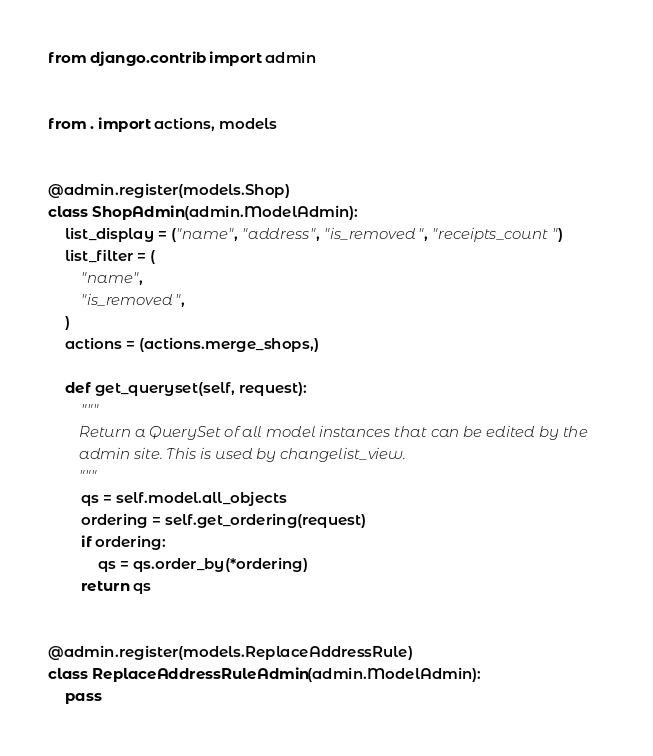<code> <loc_0><loc_0><loc_500><loc_500><_Python_>from django.contrib import admin


from . import actions, models


@admin.register(models.Shop)
class ShopAdmin(admin.ModelAdmin):
    list_display = ("name", "address", "is_removed", "receipts_count")
    list_filter = (
        "name",
        "is_removed",
    )
    actions = (actions.merge_shops,)

    def get_queryset(self, request):
        """
        Return a QuerySet of all model instances that can be edited by the
        admin site. This is used by changelist_view.
        """
        qs = self.model.all_objects
        ordering = self.get_ordering(request)
        if ordering:
            qs = qs.order_by(*ordering)
        return qs


@admin.register(models.ReplaceAddressRule)
class ReplaceAddressRuleAdmin(admin.ModelAdmin):
    pass
</code> 